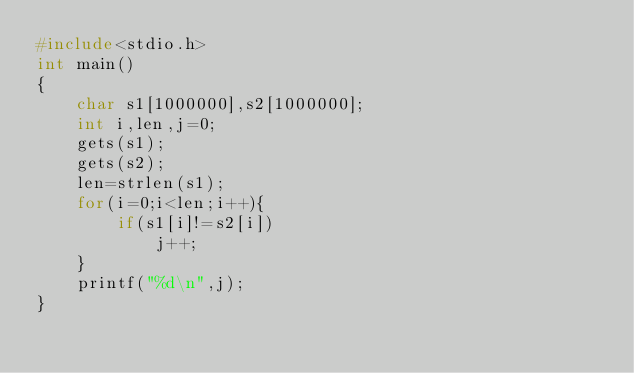<code> <loc_0><loc_0><loc_500><loc_500><_C_>#include<stdio.h>
int main()
{
    char s1[1000000],s2[1000000];
    int i,len,j=0;
    gets(s1);
    gets(s2);
    len=strlen(s1);
    for(i=0;i<len;i++){
        if(s1[i]!=s2[i])
            j++;
    }
    printf("%d\n",j);
}
</code> 